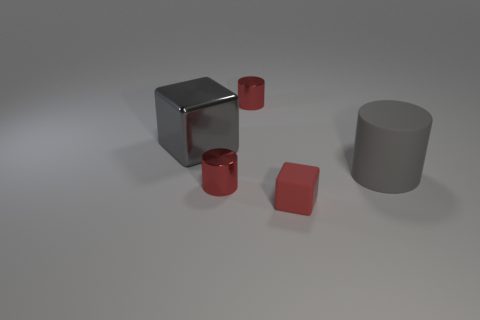Subtract all small red cylinders. How many cylinders are left? 1 Subtract 2 cylinders. How many cylinders are left? 1 Subtract all red cylinders. How many cylinders are left? 1 Add 4 brown matte cylinders. How many objects exist? 9 Subtract all cubes. How many objects are left? 3 Subtract all gray shiny cubes. Subtract all small rubber cubes. How many objects are left? 3 Add 4 large gray rubber objects. How many large gray rubber objects are left? 5 Add 3 metal cylinders. How many metal cylinders exist? 5 Subtract 1 gray cylinders. How many objects are left? 4 Subtract all blue cubes. Subtract all gray cylinders. How many cubes are left? 2 